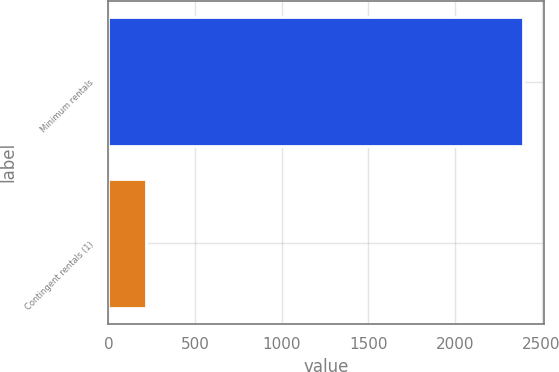Convert chart to OTSL. <chart><loc_0><loc_0><loc_500><loc_500><bar_chart><fcel>Minimum rentals<fcel>Contingent rentals (1)<nl><fcel>2394<fcel>214<nl></chart> 